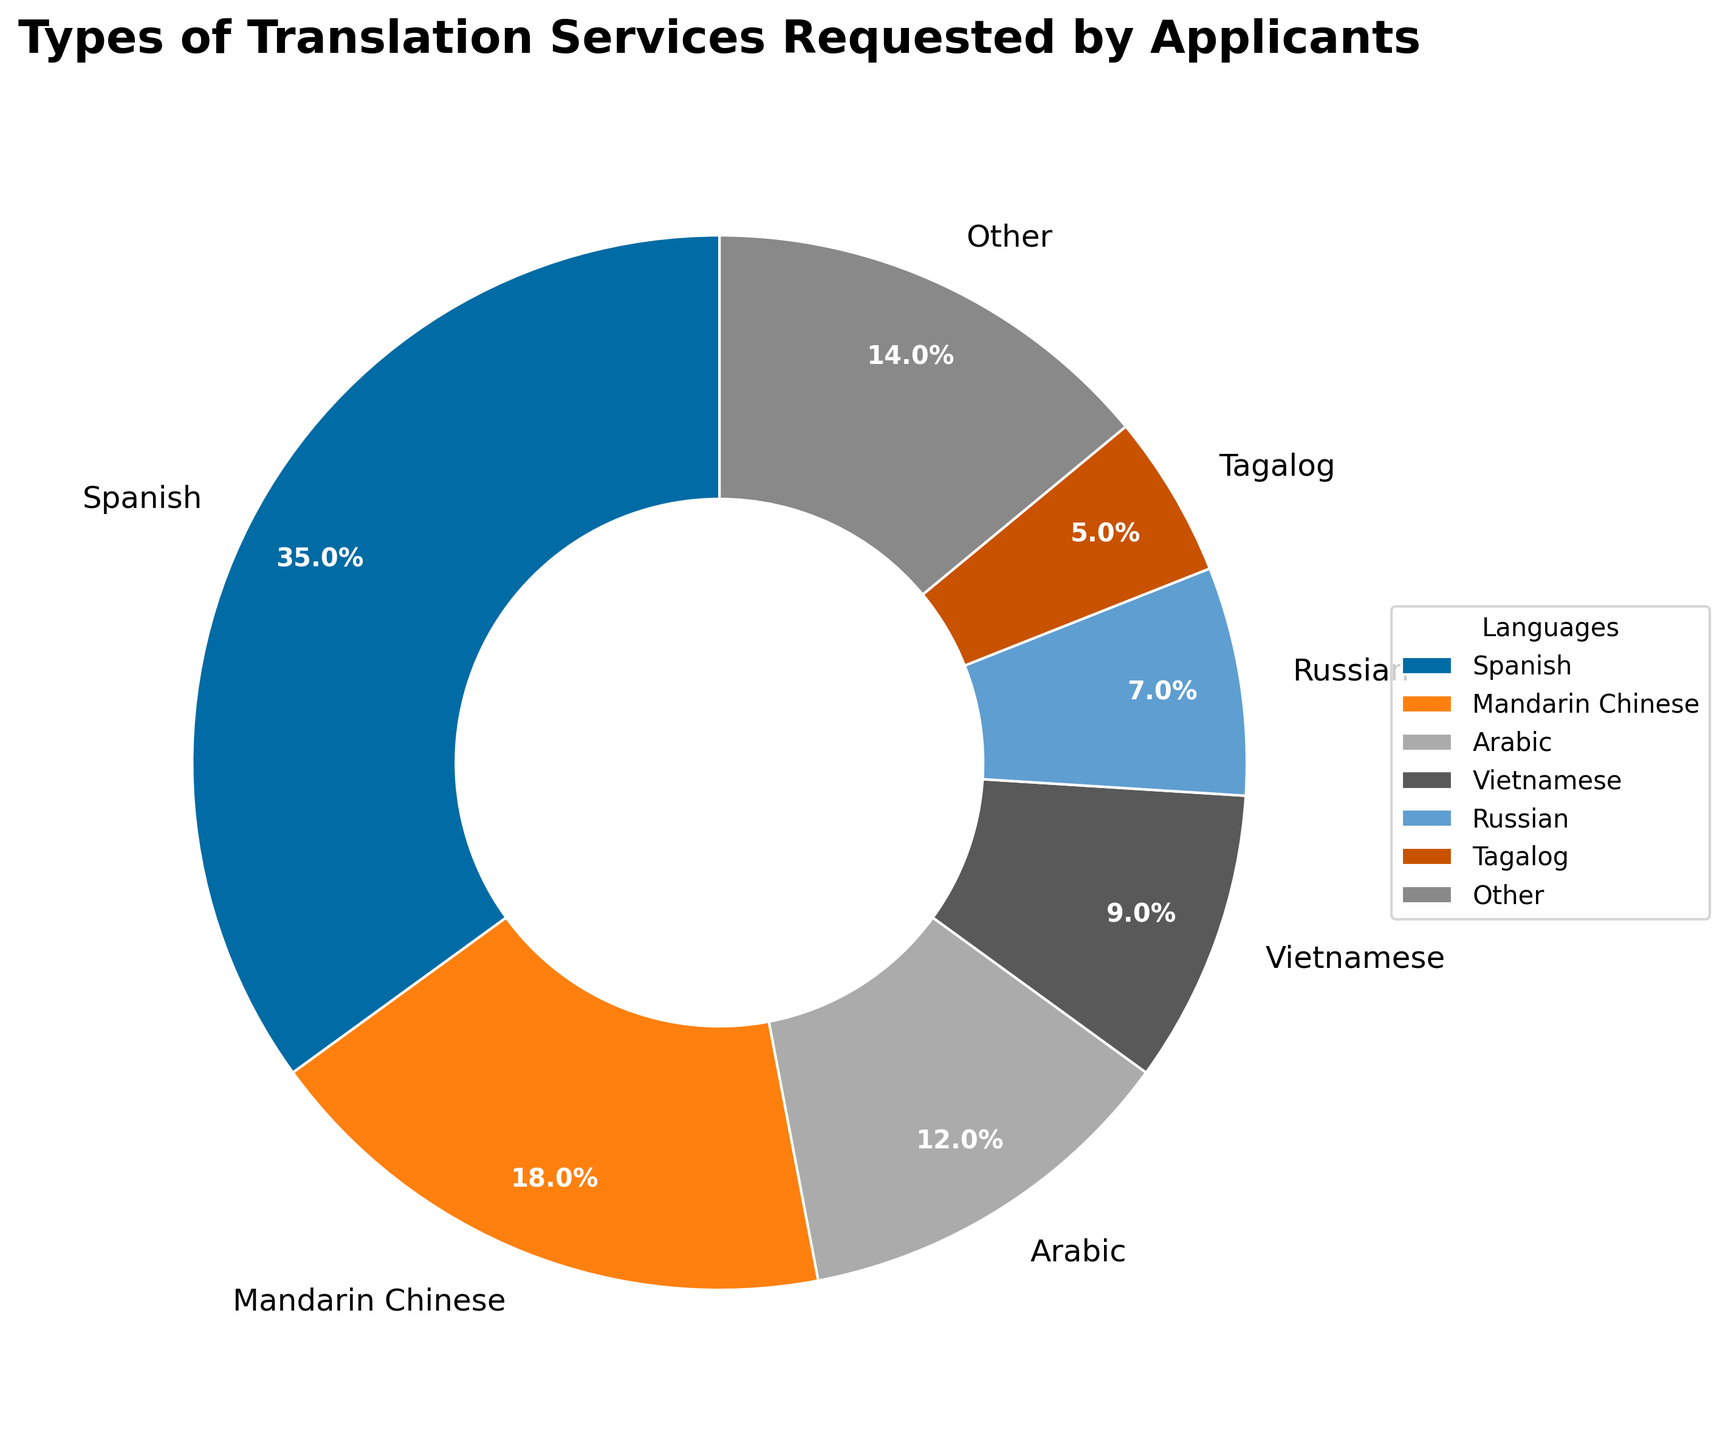What percentage of translation services requested are for Spanish? Spanish occupies the largest portion of the pie chart, labeled as "35%".
Answer: 35% Which language has a smaller percentage of requests, Vietnamese or Tagalog? Vietnamese has a percentage of 9% while Tagalog has 5%. Since 5% is less than 9%, Tagalog has a smaller percentage of requests.
Answer: Tagalog What is the combined percentage of translation services requested for Spanish and Mandarin Chinese? Spanish is 35% and Mandarin Chinese is 18%. Adding these together gives us 35% + 18% = 53%.
Answer: 53% How does the percentage of requests for Arabic compare to that for Russian? Arabic stands at 12% while Russian is at 7%. Arabic has a higher percentage than Russian, specifically 12% compared to 7%.
Answer: Arabic Which languages make up the "Other" category and what is their combined percentage? The "Other" category contains languages with percentages less than 5%: Korean (4%), French (3%), Haitian Creole (3%), Portuguese (2%), Somali (1%), and Polish (1%). Adding these gives us 4% + 3% + 3% + 2% + 1% + 1% = 14%.
Answer: Languages: Korean, French, Haitian Creole, Portuguese, Somali, Polish; Combined percentage: 14% What is the ratio of the percentage of requests for Mandarin Chinese to that for French? Mandarin Chinese has 18% and French has 3%. The ratio is 18:3 which simplifies to 6:1.
Answer: 6:1 Which languages have a request percentage greater than or equal to 5%? The languages are Spanish (35%), Mandarin Chinese (18%), Arabic (12%), Vietnamese (9%), and Russian (7%).
Answer: Spanish, Mandarin Chinese, Arabic, Vietnamese, Russian If the total number of requests is 1,000, how many requests are for Tagalog? Tagalog takes up 5% of the 1,000 requests. Therefore, 5% of 1,000 is 0.05 * 1,000 = 50.
Answer: 50 What is the percentage difference between Spanish and the sum of Korean and Haitian Creole requests? Spanish is 35%, Korean is 4%, and Haitian Creole is 3%. The sum of Korean and Haitian Creole is 4% + 3% = 7%. The difference is 35% - 7% = 28%.
Answer: 28% 